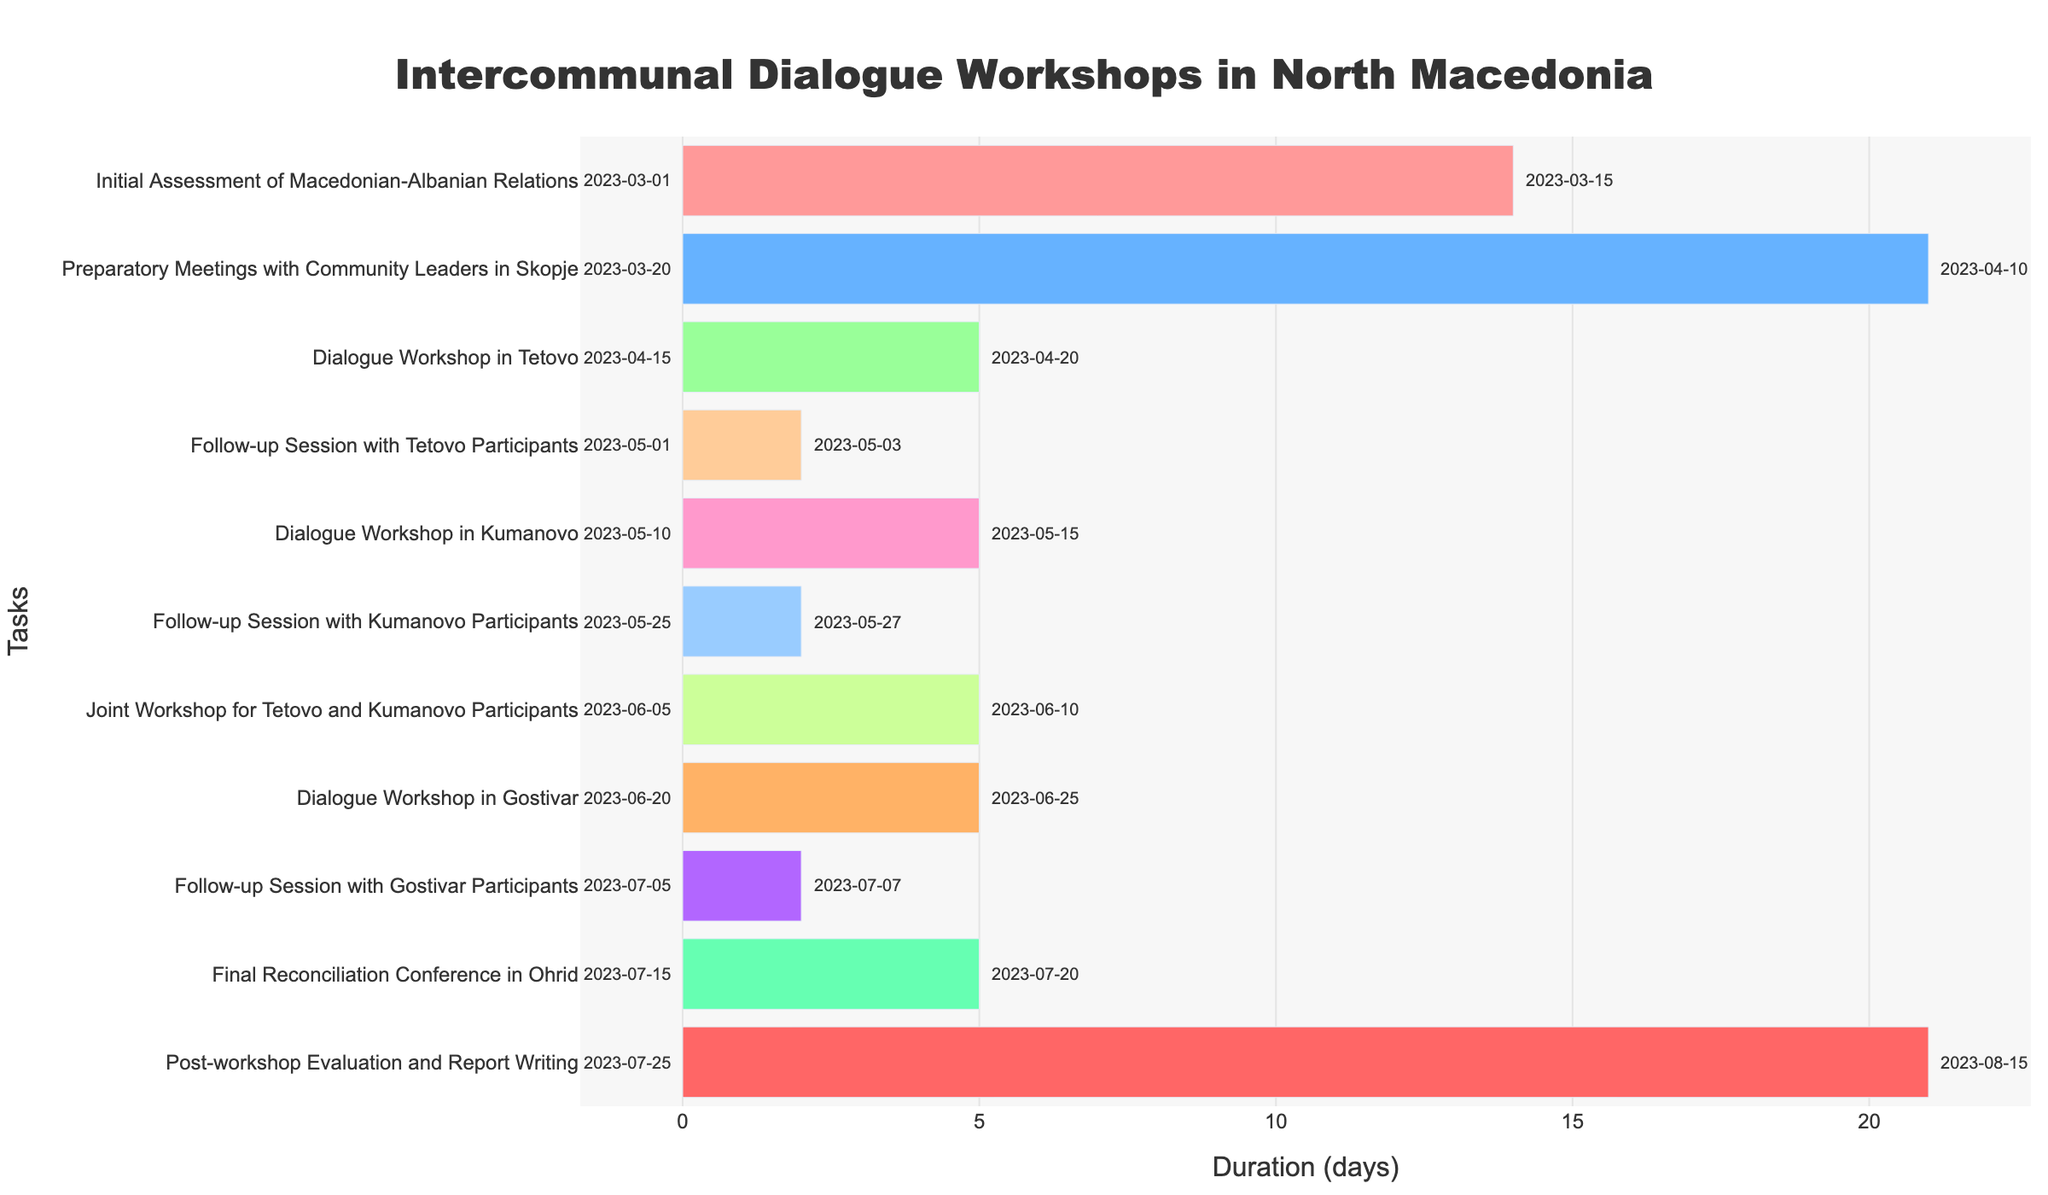What is the duration of the "Initial Assessment of Macedonian-Albanian Relations" task? The "Initial Assessment of Macedonian-Albanian Relations" task starts on 2023-03-01 and ends on 2023-03-15. The duration is the difference between these two dates, which is 14 days.
Answer: 14 days Which task has the shortest duration? By looking at the Gantt Chart, we see that the shortest duration is for the "Follow-up Session with Tetovo Participants" and "Follow-up Session with Kumanovo Participants" tasks, both lasting 3 days.
Answer: Follow-up Session with Tetovo Participants and Follow-up Session with Kumanovo Participants What is the total duration of all tasks combined? To find the total duration, add the duration of each task: 14 + 21 + 5 + 3 + 5 + 3 + 5 + 5 + 3 + 5 + 21 = 90 days.
Answer: 90 days Which task completed first? The "Initial Assessment of Macedonian-Albanian Relations" is the first task in the sequence and completes on 2023-03-15.
Answer: Initial Assessment of Macedonian-Albanian Relations What is the gap between the end of the "Dialogue Workshop in Tetovo" and the start of the "Follow-up Session with Tetovo Participants"? The "Dialogue Workshop in Tetovo" ends on 2023-04-20 and the "Follow-up Session with Tetovo Participants" starts on 2023-05-01. The gap is 11 days.
Answer: 11 days How many tasks are there before the "Final Reconciliation Conference in Ohrid"? The "Final Reconciliation Conference in Ohrid" is the 10th task in the list, so there are 9 tasks before it.
Answer: 9 tasks Which month has the most tasks starting? Counting the tasks starting in each month: March has 2, April has 2, May has 2, June has 2, and July has 2. Hence, no single month has the most tasks starting, they are evenly distributed.
Answer: Tie (March, April, May, June, July) How many tasks last exactly 5 days? By viewing the chart, the tasks that last exactly 5 days are "Dialogue Workshop in Tetovo", "Dialogue Workshop in Kumanovo", "Joint Workshop for Tetovo and Kumanovo Participants", "Dialogue Workshop in Gostivar", and "Final Reconciliation Conference in Ohrid". Thus, there are five such tasks.
Answer: 5 tasks Compare the durations of "Preparatory Meetings with Community Leaders in Skopje" and "Post-workshop Evaluation and Report Writing". Which one is longer? The "Preparatory Meetings with Community Leaders in Skopje" lasts 21 days, while "Post-workshop Evaluation and Report Writing" also lasts 21 days. So, their durations are equal.
Answer: Equal What is the sequence of tasks in June 2023? In June 2023, the sequence of tasks is "Joint Workshop for Tetovo and Kumanovo Participants" from June 5 to June 10, followed by "Dialogue Workshop in Gostivar" from June 20 to June 25.
Answer: Joint Workshop for Tetovo and Kumanovo Participants -> Dialogue Workshop in Gostivar 